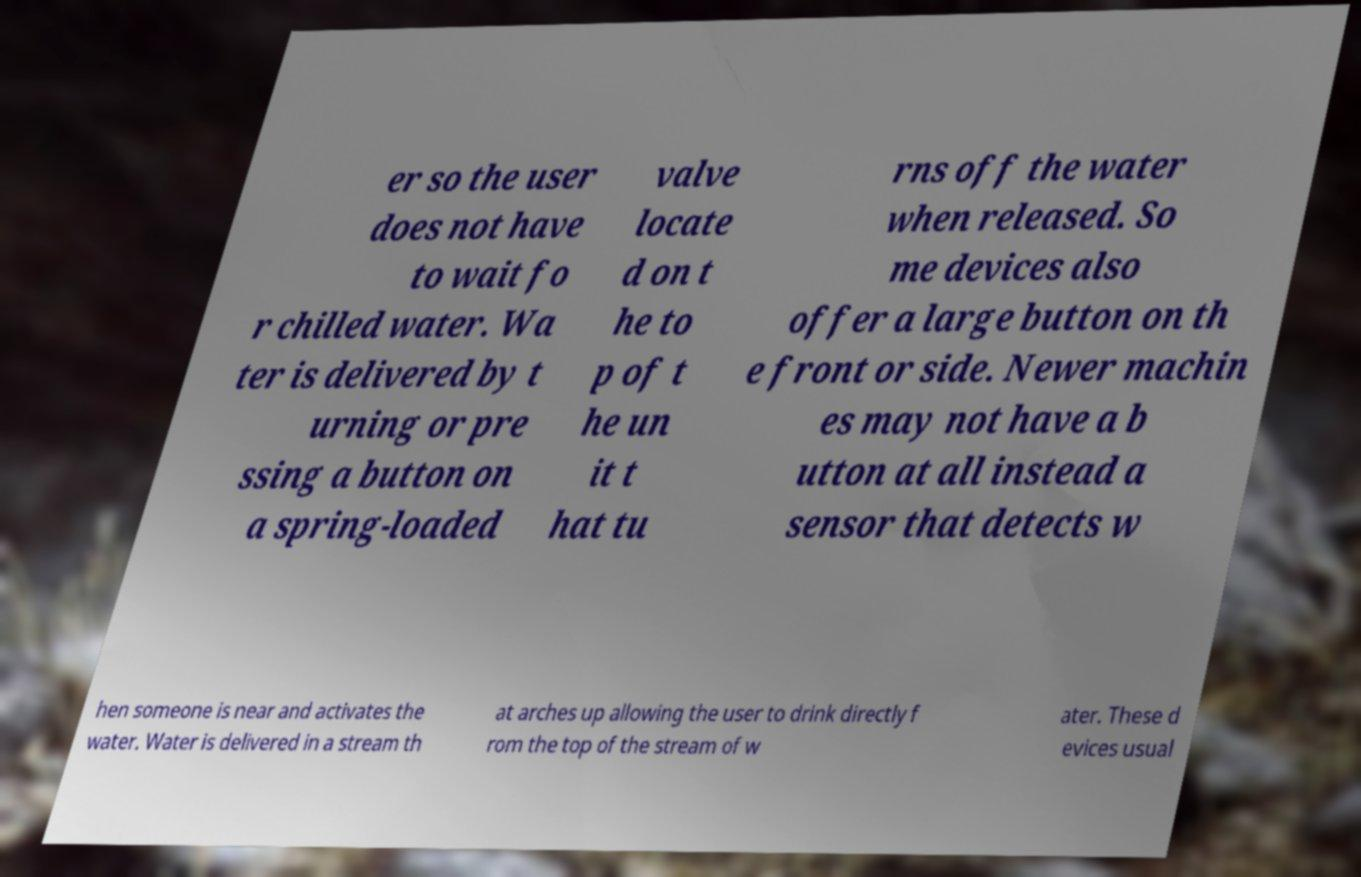Can you accurately transcribe the text from the provided image for me? er so the user does not have to wait fo r chilled water. Wa ter is delivered by t urning or pre ssing a button on a spring-loaded valve locate d on t he to p of t he un it t hat tu rns off the water when released. So me devices also offer a large button on th e front or side. Newer machin es may not have a b utton at all instead a sensor that detects w hen someone is near and activates the water. Water is delivered in a stream th at arches up allowing the user to drink directly f rom the top of the stream of w ater. These d evices usual 